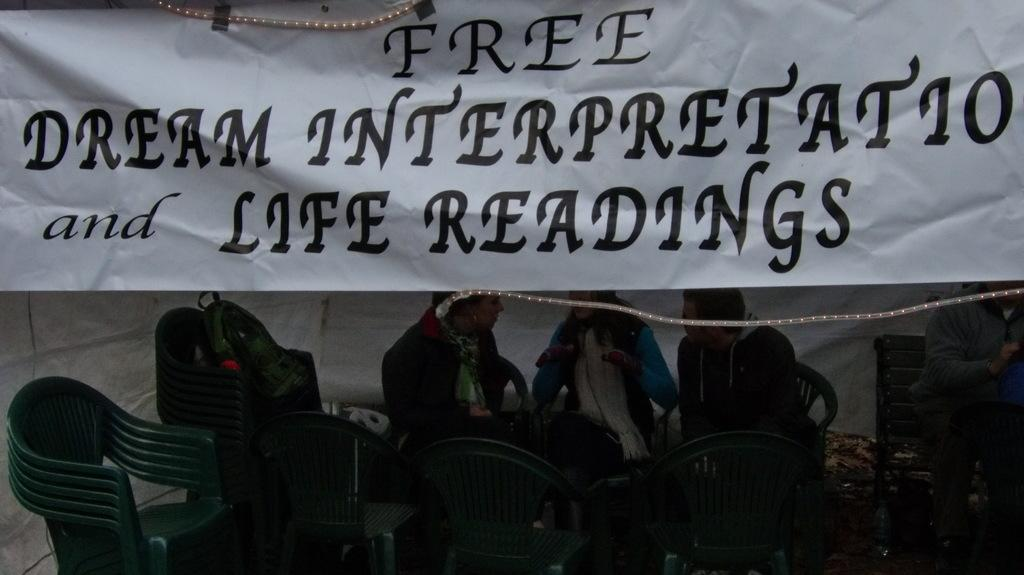What is the main feature of the banner in the image? The banner in the image has lights. What can be seen in the background of the image? There are persons and chairs in the background of the image. How many dimes are placed on the chairs in the image? There is no mention of dimes in the image, so it cannot be determined if any are present on the chairs. 